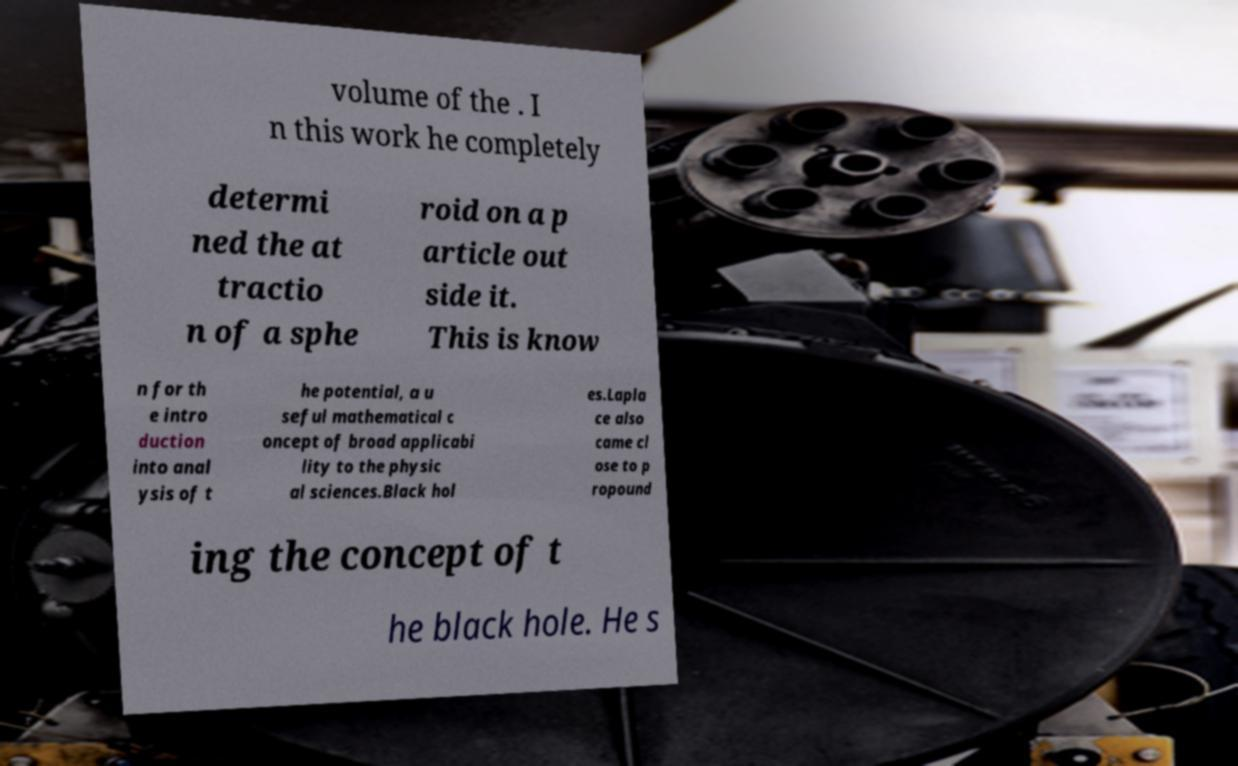For documentation purposes, I need the text within this image transcribed. Could you provide that? volume of the . I n this work he completely determi ned the at tractio n of a sphe roid on a p article out side it. This is know n for th e intro duction into anal ysis of t he potential, a u seful mathematical c oncept of broad applicabi lity to the physic al sciences.Black hol es.Lapla ce also came cl ose to p ropound ing the concept of t he black hole. He s 